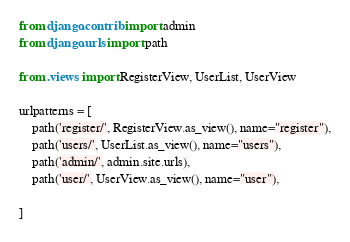<code> <loc_0><loc_0><loc_500><loc_500><_Python_>from django.contrib import admin
from django.urls import path

from .views import RegisterView, UserList, UserView

urlpatterns = [
    path('register/', RegisterView.as_view(), name="register"),
    path('users/', UserList.as_view(), name="users"),
    path('admin/', admin.site.urls),
    path('user/', UserView.as_view(), name="user"),

]
</code> 